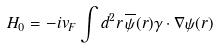<formula> <loc_0><loc_0><loc_500><loc_500>H _ { 0 } = - i v _ { F } \int d ^ { 2 } r \, \overline { \psi } ( { r } ) \gamma \cdot \nabla \psi ( { r } )</formula> 